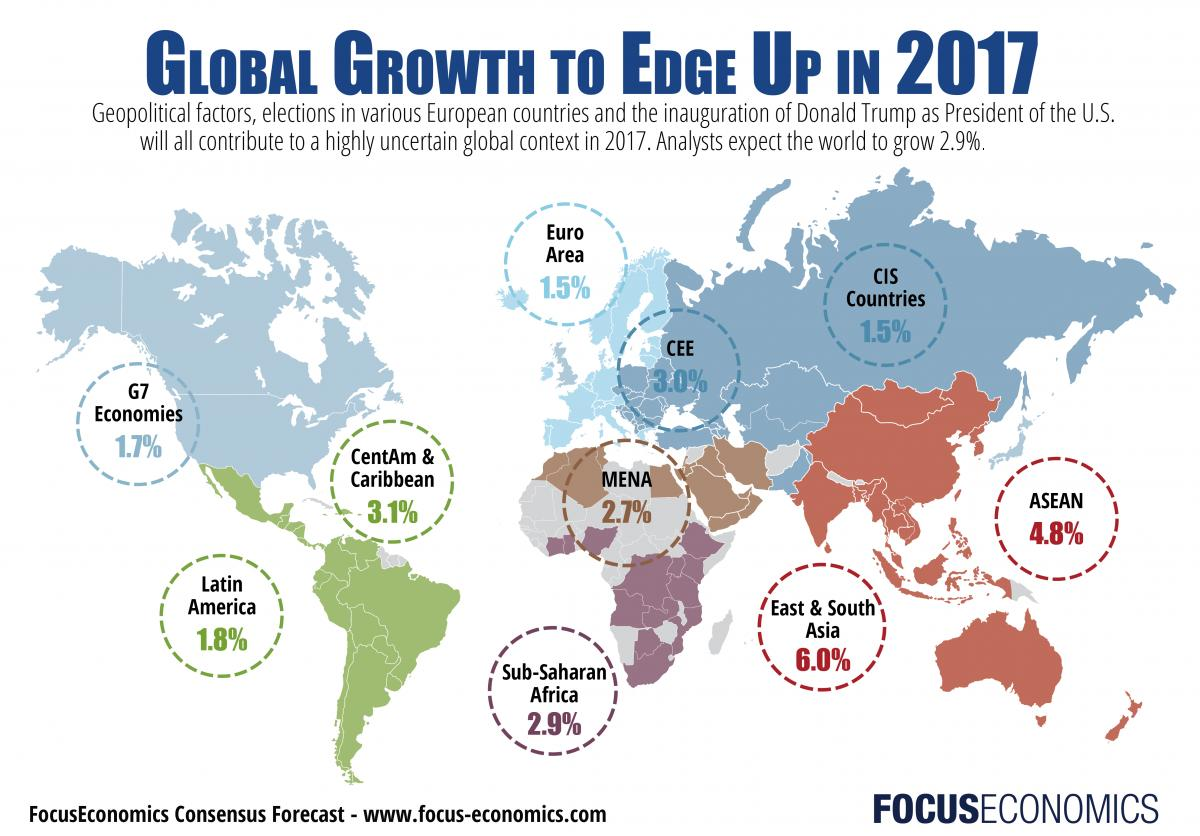Specify some key components in this picture. The lowest growth rate is 4.5%, and the highest growth rate is 20.3%. Therefore, the difference in growth rate between the lowest and highest is 15.8%. The East & South Asia region is projected to experience the most significant growth in the future. The growth rate of projects in the MENA region is expected to be 2.7% The growth rate for G7 economies is expected to be 1.7%. The Euro Area and CIS Countries have the same growth rate. 